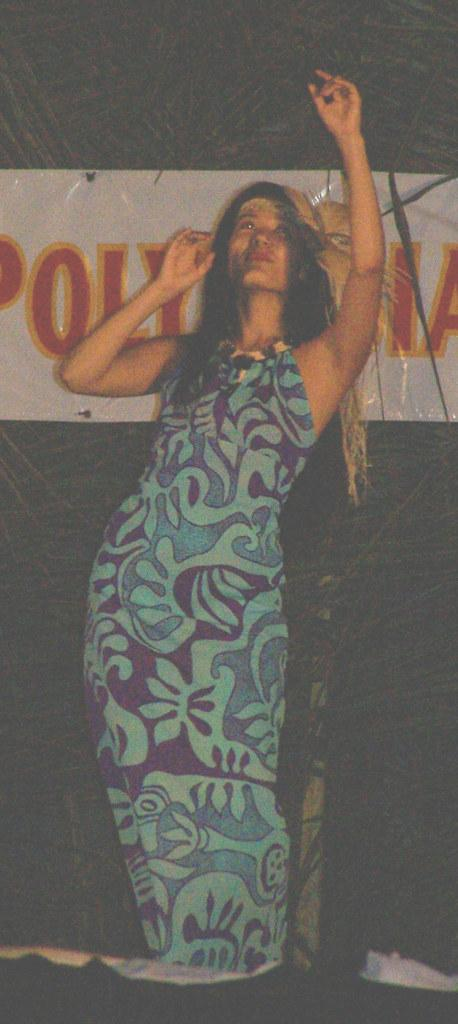Who is the main subject in the image? There is a woman in the image. What is the woman doing in the image? The woman appears to be dancing. What else can be seen in the image besides the woman? There is a banner in the image. Can you describe the banner in the image? The banner is white in color, and there is red text on it. How many spies are observing the woman's dance from a distance in the image? There are no spies observing the woman's dance in the image. What is the size of the banner in the image? The size of the banner cannot be determined from the image alone. 